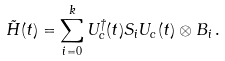<formula> <loc_0><loc_0><loc_500><loc_500>\tilde { H } ( t ) = \sum _ { i = 0 } ^ { k } U ^ { \dag } _ { c } ( t ) S _ { i } U _ { c } ( t ) \otimes B _ { i } \, .</formula> 